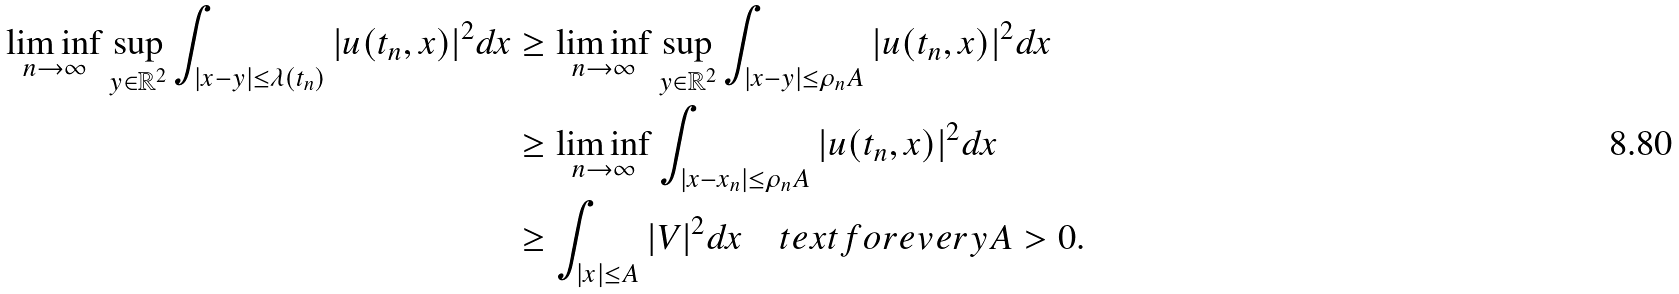<formula> <loc_0><loc_0><loc_500><loc_500>\liminf _ { n \rightarrow \infty } \sup _ { y \in \mathbb { R } ^ { 2 } } \int _ { | x - y | \leq \lambda ( t _ { n } ) } | u ( t _ { n } , x ) | ^ { 2 } d x & \geq \liminf _ { n \rightarrow \infty } \sup _ { y \in \mathbb { R } ^ { 2 } } \int _ { | x - y | \leq \rho _ { n } A } | u ( t _ { n } , x ) | ^ { 2 } d x \\ & \geq \liminf _ { n \rightarrow \infty } \int _ { | x - x _ { n } | \leq \rho _ { n } A } | u ( t _ { n } , x ) | ^ { 2 } d x \\ & \geq \int _ { | x | \leq A } | V | ^ { 2 } d x \quad t e x t { f o r e v e r y } A > 0 .</formula> 